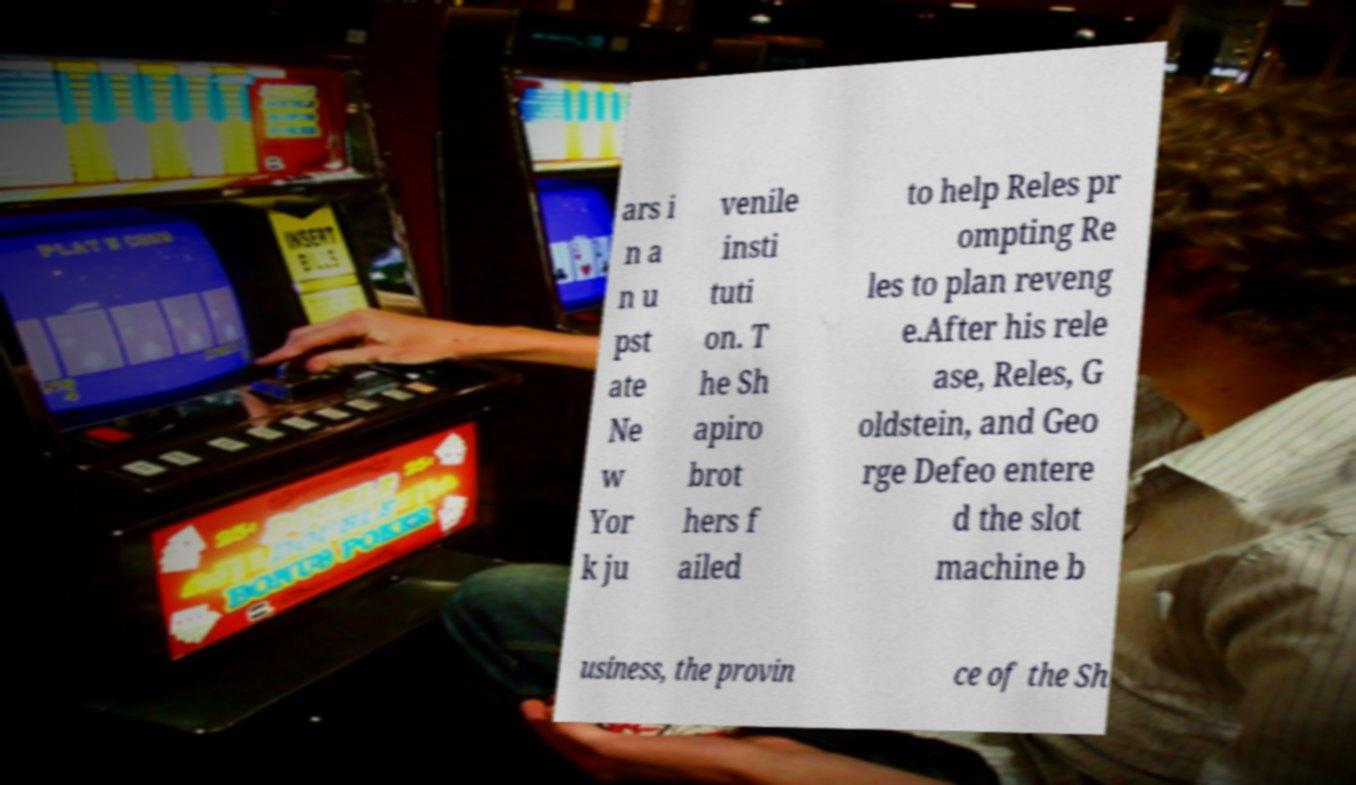Please read and relay the text visible in this image. What does it say? ars i n a n u pst ate Ne w Yor k ju venile insti tuti on. T he Sh apiro brot hers f ailed to help Reles pr ompting Re les to plan reveng e.After his rele ase, Reles, G oldstein, and Geo rge Defeo entere d the slot machine b usiness, the provin ce of the Sh 